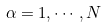<formula> <loc_0><loc_0><loc_500><loc_500>\alpha = 1 , \cdots , N</formula> 